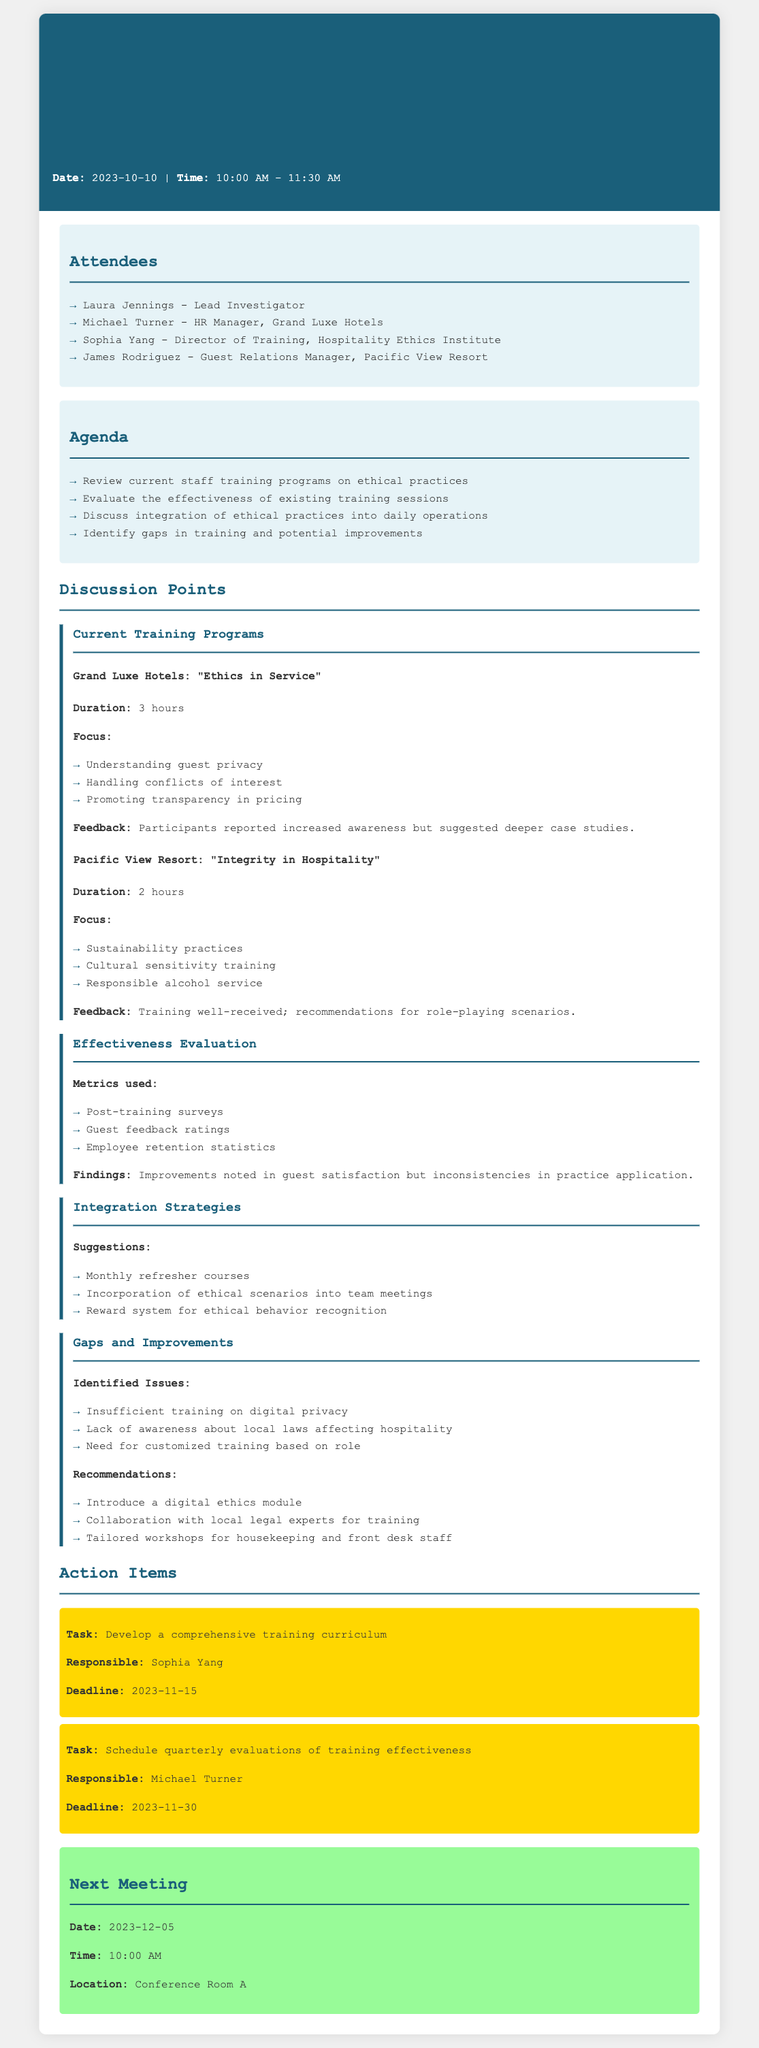What is the date of the meeting? The date of the meeting is specified in the header section of the document.
Answer: 2023-10-10 Who is the Lead Investigator? The Lead Investigator is listed in the attendees section of the document.
Answer: Laura Jennings How long is the training program "Ethics in Service"? The duration of the training program is mentioned under the discussion point for Grand Luxe Hotels.
Answer: 3 hours What are the identified gaps in training? The gaps mentioned in the discussion point address issues across various training aspects.
Answer: Insufficient training on digital privacy What is the deadline for developing a comprehensive training curriculum? The deadline is specified in the action items section of the document.
Answer: 2023-11-15 Which hotel focuses on "Integrity in Hospitality"? This information refers to the training programs discussed under the current training programs section.
Answer: Pacific View Resort What is one of the metrics used to evaluate training effectiveness? The metrics are listed under the effectiveness evaluation discussion point.
Answer: Post-training surveys Who is responsible for scheduling quarterly evaluations of training effectiveness? The responsible person is mentioned in the action items section.
Answer: Michael Turner 